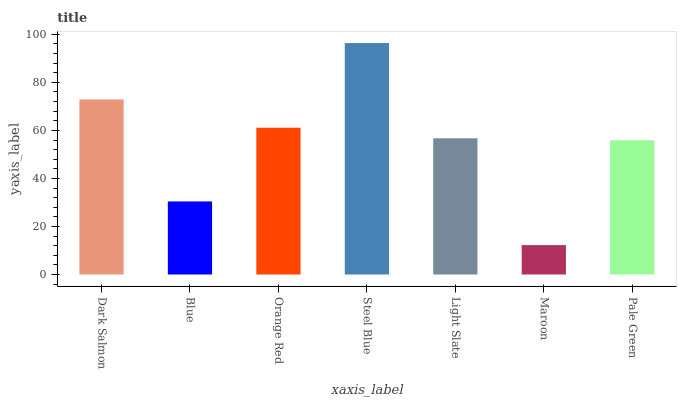Is Maroon the minimum?
Answer yes or no. Yes. Is Steel Blue the maximum?
Answer yes or no. Yes. Is Blue the minimum?
Answer yes or no. No. Is Blue the maximum?
Answer yes or no. No. Is Dark Salmon greater than Blue?
Answer yes or no. Yes. Is Blue less than Dark Salmon?
Answer yes or no. Yes. Is Blue greater than Dark Salmon?
Answer yes or no. No. Is Dark Salmon less than Blue?
Answer yes or no. No. Is Light Slate the high median?
Answer yes or no. Yes. Is Light Slate the low median?
Answer yes or no. Yes. Is Dark Salmon the high median?
Answer yes or no. No. Is Steel Blue the low median?
Answer yes or no. No. 